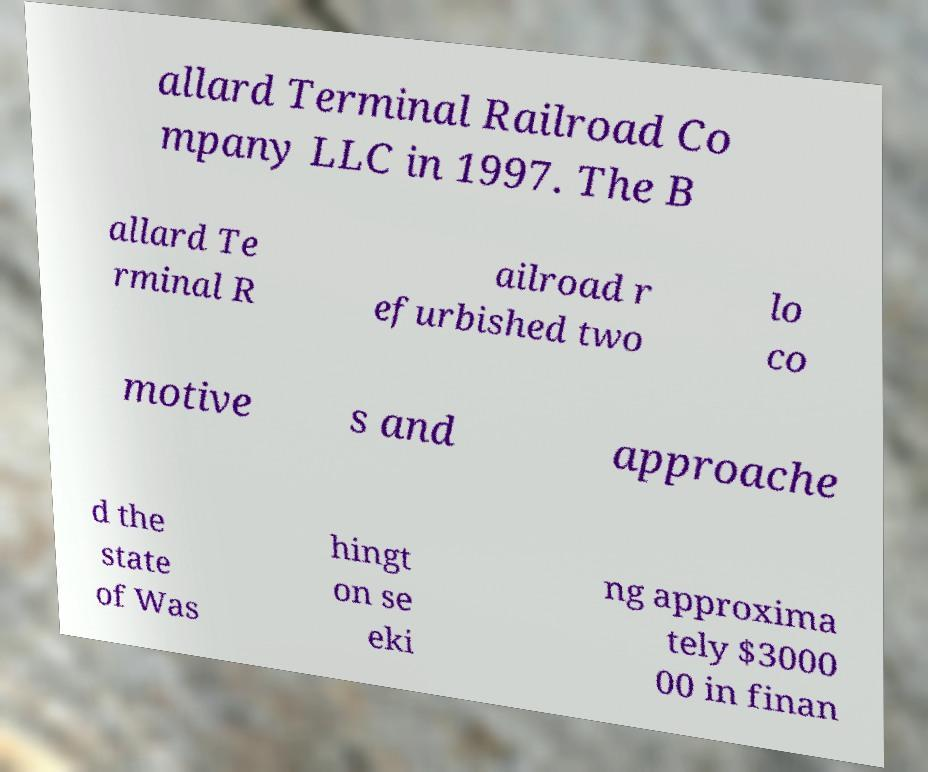Could you extract and type out the text from this image? allard Terminal Railroad Co mpany LLC in 1997. The B allard Te rminal R ailroad r efurbished two lo co motive s and approache d the state of Was hingt on se eki ng approxima tely $3000 00 in finan 